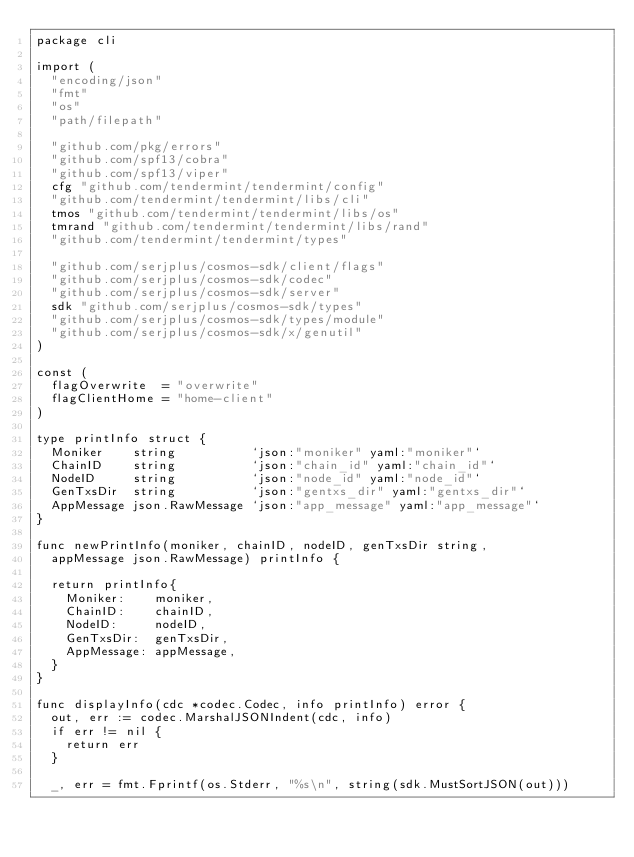Convert code to text. <code><loc_0><loc_0><loc_500><loc_500><_Go_>package cli

import (
	"encoding/json"
	"fmt"
	"os"
	"path/filepath"

	"github.com/pkg/errors"
	"github.com/spf13/cobra"
	"github.com/spf13/viper"
	cfg "github.com/tendermint/tendermint/config"
	"github.com/tendermint/tendermint/libs/cli"
	tmos "github.com/tendermint/tendermint/libs/os"
	tmrand "github.com/tendermint/tendermint/libs/rand"
	"github.com/tendermint/tendermint/types"

	"github.com/serjplus/cosmos-sdk/client/flags"
	"github.com/serjplus/cosmos-sdk/codec"
	"github.com/serjplus/cosmos-sdk/server"
	sdk "github.com/serjplus/cosmos-sdk/types"
	"github.com/serjplus/cosmos-sdk/types/module"
	"github.com/serjplus/cosmos-sdk/x/genutil"
)

const (
	flagOverwrite  = "overwrite"
	flagClientHome = "home-client"
)

type printInfo struct {
	Moniker    string          `json:"moniker" yaml:"moniker"`
	ChainID    string          `json:"chain_id" yaml:"chain_id"`
	NodeID     string          `json:"node_id" yaml:"node_id"`
	GenTxsDir  string          `json:"gentxs_dir" yaml:"gentxs_dir"`
	AppMessage json.RawMessage `json:"app_message" yaml:"app_message"`
}

func newPrintInfo(moniker, chainID, nodeID, genTxsDir string,
	appMessage json.RawMessage) printInfo {

	return printInfo{
		Moniker:    moniker,
		ChainID:    chainID,
		NodeID:     nodeID,
		GenTxsDir:  genTxsDir,
		AppMessage: appMessage,
	}
}

func displayInfo(cdc *codec.Codec, info printInfo) error {
	out, err := codec.MarshalJSONIndent(cdc, info)
	if err != nil {
		return err
	}

	_, err = fmt.Fprintf(os.Stderr, "%s\n", string(sdk.MustSortJSON(out)))</code> 